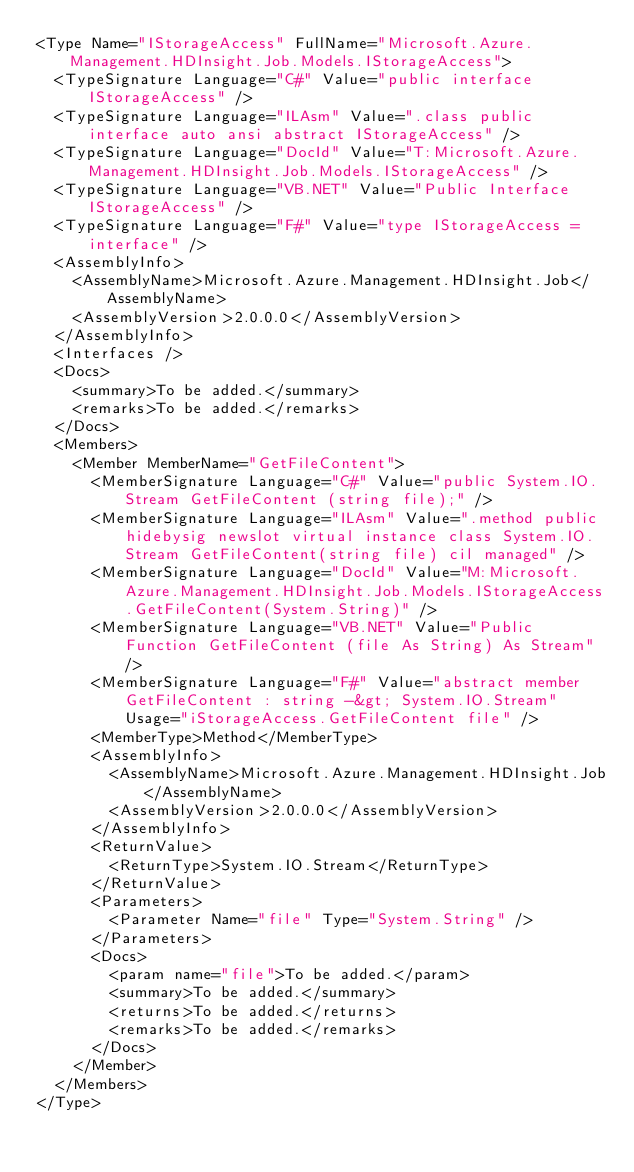Convert code to text. <code><loc_0><loc_0><loc_500><loc_500><_XML_><Type Name="IStorageAccess" FullName="Microsoft.Azure.Management.HDInsight.Job.Models.IStorageAccess">
  <TypeSignature Language="C#" Value="public interface IStorageAccess" />
  <TypeSignature Language="ILAsm" Value=".class public interface auto ansi abstract IStorageAccess" />
  <TypeSignature Language="DocId" Value="T:Microsoft.Azure.Management.HDInsight.Job.Models.IStorageAccess" />
  <TypeSignature Language="VB.NET" Value="Public Interface IStorageAccess" />
  <TypeSignature Language="F#" Value="type IStorageAccess = interface" />
  <AssemblyInfo>
    <AssemblyName>Microsoft.Azure.Management.HDInsight.Job</AssemblyName>
    <AssemblyVersion>2.0.0.0</AssemblyVersion>
  </AssemblyInfo>
  <Interfaces />
  <Docs>
    <summary>To be added.</summary>
    <remarks>To be added.</remarks>
  </Docs>
  <Members>
    <Member MemberName="GetFileContent">
      <MemberSignature Language="C#" Value="public System.IO.Stream GetFileContent (string file);" />
      <MemberSignature Language="ILAsm" Value=".method public hidebysig newslot virtual instance class System.IO.Stream GetFileContent(string file) cil managed" />
      <MemberSignature Language="DocId" Value="M:Microsoft.Azure.Management.HDInsight.Job.Models.IStorageAccess.GetFileContent(System.String)" />
      <MemberSignature Language="VB.NET" Value="Public Function GetFileContent (file As String) As Stream" />
      <MemberSignature Language="F#" Value="abstract member GetFileContent : string -&gt; System.IO.Stream" Usage="iStorageAccess.GetFileContent file" />
      <MemberType>Method</MemberType>
      <AssemblyInfo>
        <AssemblyName>Microsoft.Azure.Management.HDInsight.Job</AssemblyName>
        <AssemblyVersion>2.0.0.0</AssemblyVersion>
      </AssemblyInfo>
      <ReturnValue>
        <ReturnType>System.IO.Stream</ReturnType>
      </ReturnValue>
      <Parameters>
        <Parameter Name="file" Type="System.String" />
      </Parameters>
      <Docs>
        <param name="file">To be added.</param>
        <summary>To be added.</summary>
        <returns>To be added.</returns>
        <remarks>To be added.</remarks>
      </Docs>
    </Member>
  </Members>
</Type>
</code> 